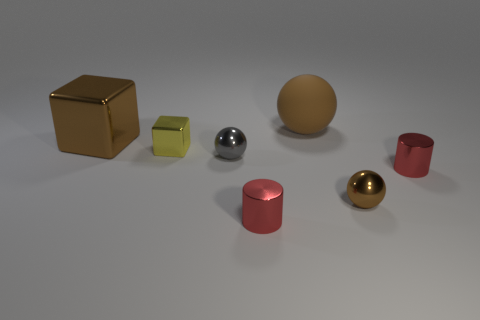Is there any other thing that has the same material as the large brown ball?
Your answer should be compact. No. There is a brown matte ball; is it the same size as the metallic cylinder that is right of the brown matte object?
Keep it short and to the point. No. There is another large metal object that is the same shape as the yellow metallic thing; what color is it?
Provide a succinct answer. Brown. There is a red thing to the right of the large sphere; how many metallic things are behind it?
Make the answer very short. 3. How many spheres are either tiny gray metallic objects or brown objects?
Ensure brevity in your answer.  3. Is there a tiny gray metallic thing?
Offer a terse response. Yes. There is a brown metallic thing that is the same shape as the brown matte object; what size is it?
Provide a short and direct response. Small. There is a red thing that is to the left of the brown rubber thing on the right side of the tiny gray metal object; what shape is it?
Make the answer very short. Cylinder. How many gray things are either big blocks or metallic things?
Keep it short and to the point. 1. The big rubber ball has what color?
Offer a very short reply. Brown. 